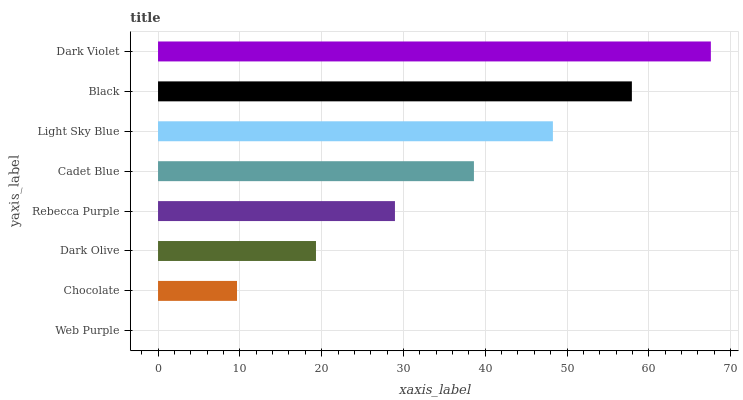Is Web Purple the minimum?
Answer yes or no. Yes. Is Dark Violet the maximum?
Answer yes or no. Yes. Is Chocolate the minimum?
Answer yes or no. No. Is Chocolate the maximum?
Answer yes or no. No. Is Chocolate greater than Web Purple?
Answer yes or no. Yes. Is Web Purple less than Chocolate?
Answer yes or no. Yes. Is Web Purple greater than Chocolate?
Answer yes or no. No. Is Chocolate less than Web Purple?
Answer yes or no. No. Is Cadet Blue the high median?
Answer yes or no. Yes. Is Rebecca Purple the low median?
Answer yes or no. Yes. Is Web Purple the high median?
Answer yes or no. No. Is Cadet Blue the low median?
Answer yes or no. No. 